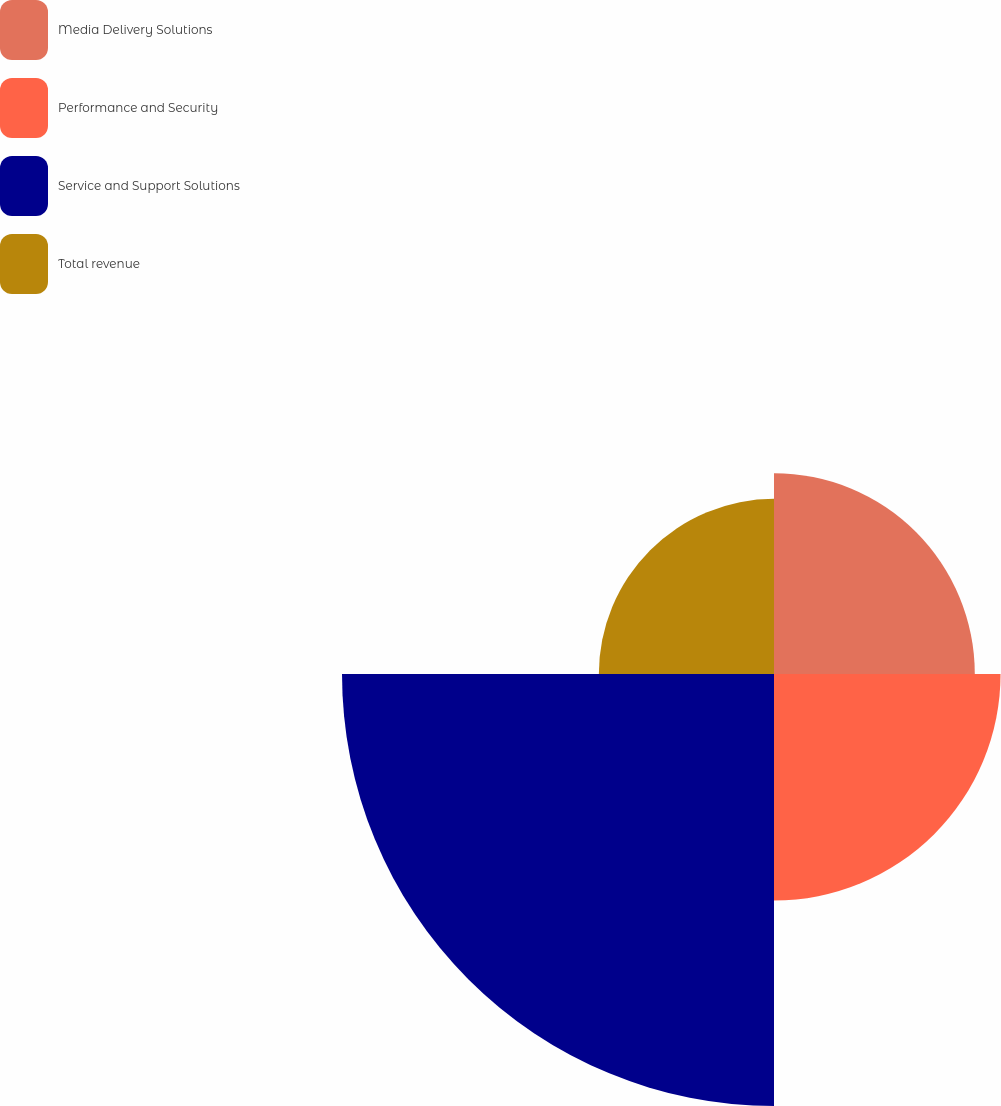Convert chart to OTSL. <chart><loc_0><loc_0><loc_500><loc_500><pie_chart><fcel>Media Delivery Solutions<fcel>Performance and Security<fcel>Service and Support Solutions<fcel>Total revenue<nl><fcel>19.41%<fcel>21.9%<fcel>41.76%<fcel>16.93%<nl></chart> 